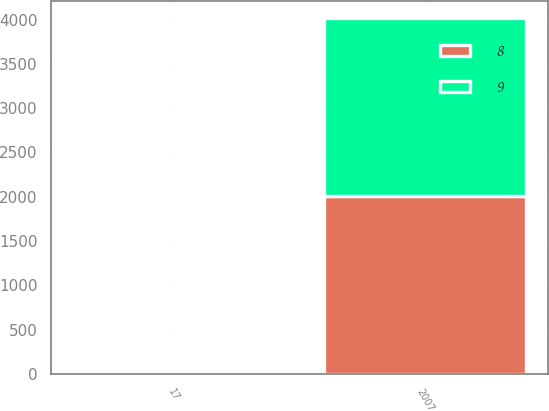<chart> <loc_0><loc_0><loc_500><loc_500><stacked_bar_chart><ecel><fcel>2007<fcel>17<nl><fcel>8<fcel>2007<fcel>9<nl><fcel>9<fcel>2007<fcel>8<nl></chart> 